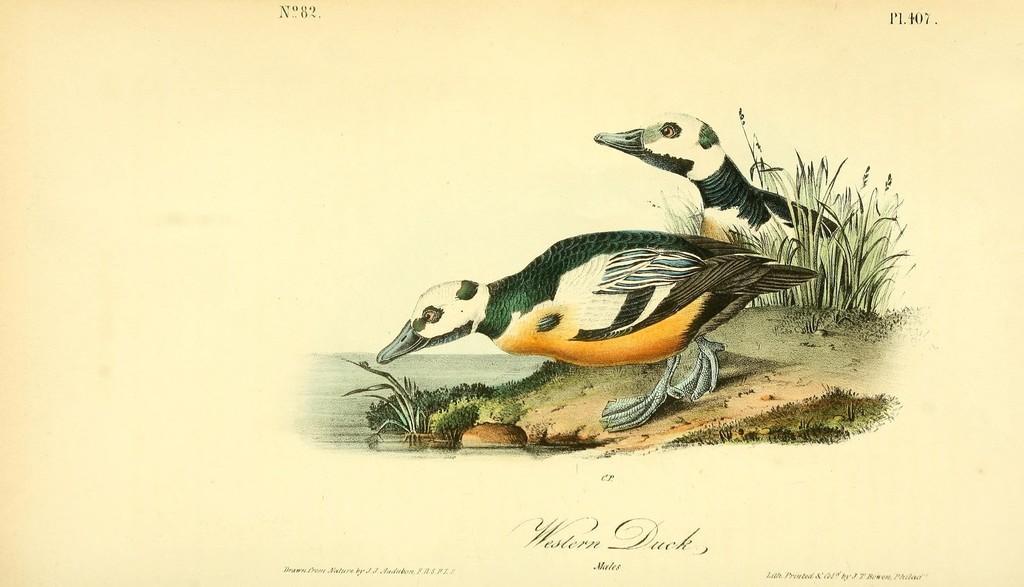In one or two sentences, can you explain what this image depicts? This image is a painting. There are two birds present near the lake. Image also consists of plants. There is a black color text on the paper. 